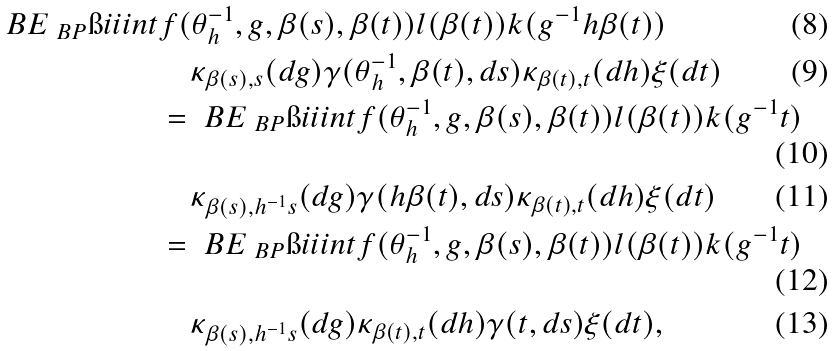<formula> <loc_0><loc_0><loc_500><loc_500>\ B E _ { \ B P } \i i i i n t & f ( \theta ^ { - 1 } _ { h } , g , \beta ( s ) , \beta ( t ) ) l ( \beta ( t ) ) k ( g ^ { - 1 } h \beta ( t ) ) \\ & \quad \kappa _ { \beta ( s ) , s } ( d g ) \gamma ( \theta ^ { - 1 } _ { h } , \beta ( t ) , d s ) \kappa _ { \beta ( t ) , t } ( d h ) \xi ( d t ) \\ & = \ B E _ { \ B P } \i i i i n t f ( \theta ^ { - 1 } _ { h } , g , \beta ( s ) , \beta ( t ) ) l ( \beta ( t ) ) k ( g ^ { - 1 } t ) \\ & \quad \kappa _ { \beta ( s ) , h ^ { - 1 } s } ( d g ) \gamma ( h \beta ( t ) , d s ) \kappa _ { \beta ( t ) , t } ( d h ) \xi ( d t ) \\ & = \ B E _ { \ B P } \i i i i n t f ( \theta ^ { - 1 } _ { h } , g , \beta ( s ) , \beta ( t ) ) l ( \beta ( t ) ) k ( g ^ { - 1 } t ) \\ & \quad \kappa _ { \beta ( s ) , h ^ { - 1 } s } ( d g ) \kappa _ { \beta ( t ) , t } ( d h ) \gamma ( t , d s ) \xi ( d t ) ,</formula> 